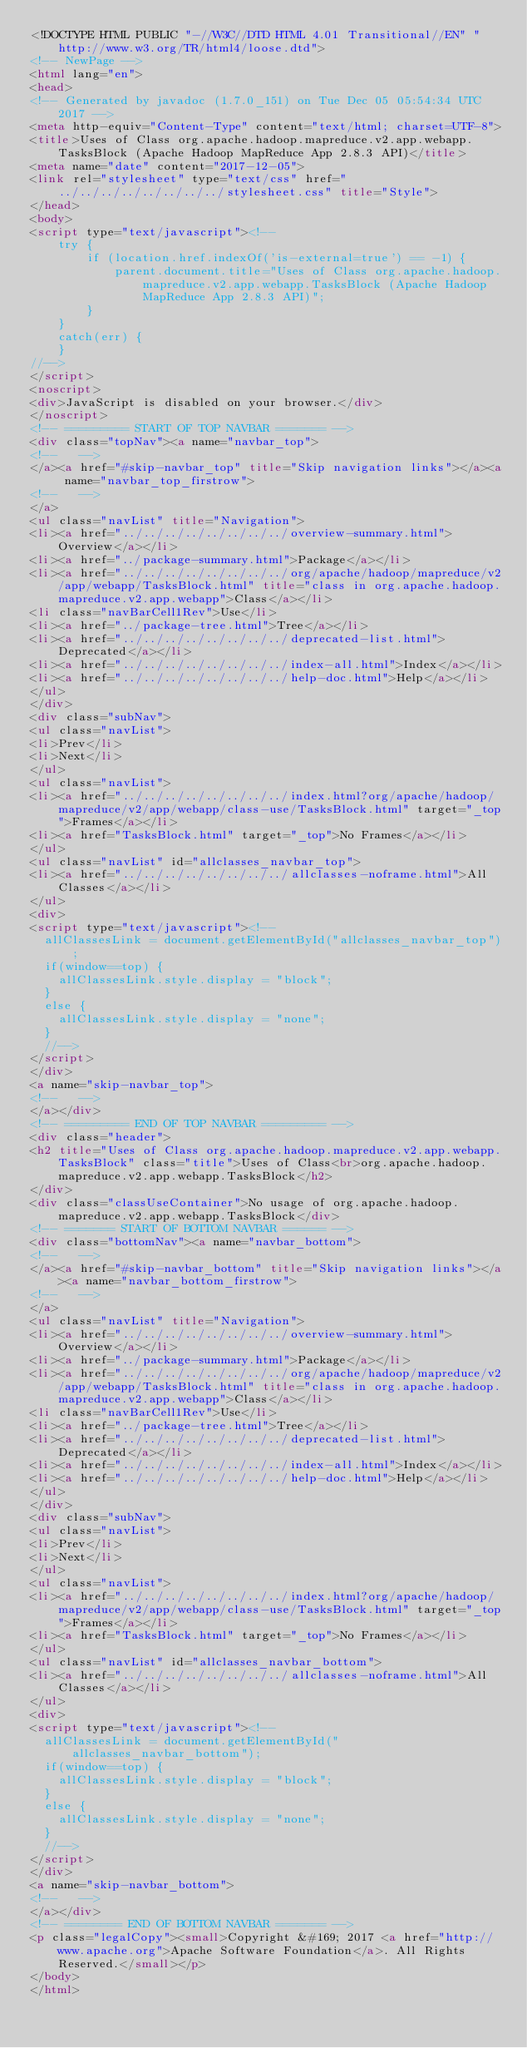Convert code to text. <code><loc_0><loc_0><loc_500><loc_500><_HTML_><!DOCTYPE HTML PUBLIC "-//W3C//DTD HTML 4.01 Transitional//EN" "http://www.w3.org/TR/html4/loose.dtd">
<!-- NewPage -->
<html lang="en">
<head>
<!-- Generated by javadoc (1.7.0_151) on Tue Dec 05 05:54:34 UTC 2017 -->
<meta http-equiv="Content-Type" content="text/html; charset=UTF-8">
<title>Uses of Class org.apache.hadoop.mapreduce.v2.app.webapp.TasksBlock (Apache Hadoop MapReduce App 2.8.3 API)</title>
<meta name="date" content="2017-12-05">
<link rel="stylesheet" type="text/css" href="../../../../../../../../stylesheet.css" title="Style">
</head>
<body>
<script type="text/javascript"><!--
    try {
        if (location.href.indexOf('is-external=true') == -1) {
            parent.document.title="Uses of Class org.apache.hadoop.mapreduce.v2.app.webapp.TasksBlock (Apache Hadoop MapReduce App 2.8.3 API)";
        }
    }
    catch(err) {
    }
//-->
</script>
<noscript>
<div>JavaScript is disabled on your browser.</div>
</noscript>
<!-- ========= START OF TOP NAVBAR ======= -->
<div class="topNav"><a name="navbar_top">
<!--   -->
</a><a href="#skip-navbar_top" title="Skip navigation links"></a><a name="navbar_top_firstrow">
<!--   -->
</a>
<ul class="navList" title="Navigation">
<li><a href="../../../../../../../../overview-summary.html">Overview</a></li>
<li><a href="../package-summary.html">Package</a></li>
<li><a href="../../../../../../../../org/apache/hadoop/mapreduce/v2/app/webapp/TasksBlock.html" title="class in org.apache.hadoop.mapreduce.v2.app.webapp">Class</a></li>
<li class="navBarCell1Rev">Use</li>
<li><a href="../package-tree.html">Tree</a></li>
<li><a href="../../../../../../../../deprecated-list.html">Deprecated</a></li>
<li><a href="../../../../../../../../index-all.html">Index</a></li>
<li><a href="../../../../../../../../help-doc.html">Help</a></li>
</ul>
</div>
<div class="subNav">
<ul class="navList">
<li>Prev</li>
<li>Next</li>
</ul>
<ul class="navList">
<li><a href="../../../../../../../../index.html?org/apache/hadoop/mapreduce/v2/app/webapp/class-use/TasksBlock.html" target="_top">Frames</a></li>
<li><a href="TasksBlock.html" target="_top">No Frames</a></li>
</ul>
<ul class="navList" id="allclasses_navbar_top">
<li><a href="../../../../../../../../allclasses-noframe.html">All Classes</a></li>
</ul>
<div>
<script type="text/javascript"><!--
  allClassesLink = document.getElementById("allclasses_navbar_top");
  if(window==top) {
    allClassesLink.style.display = "block";
  }
  else {
    allClassesLink.style.display = "none";
  }
  //-->
</script>
</div>
<a name="skip-navbar_top">
<!--   -->
</a></div>
<!-- ========= END OF TOP NAVBAR ========= -->
<div class="header">
<h2 title="Uses of Class org.apache.hadoop.mapreduce.v2.app.webapp.TasksBlock" class="title">Uses of Class<br>org.apache.hadoop.mapreduce.v2.app.webapp.TasksBlock</h2>
</div>
<div class="classUseContainer">No usage of org.apache.hadoop.mapreduce.v2.app.webapp.TasksBlock</div>
<!-- ======= START OF BOTTOM NAVBAR ====== -->
<div class="bottomNav"><a name="navbar_bottom">
<!--   -->
</a><a href="#skip-navbar_bottom" title="Skip navigation links"></a><a name="navbar_bottom_firstrow">
<!--   -->
</a>
<ul class="navList" title="Navigation">
<li><a href="../../../../../../../../overview-summary.html">Overview</a></li>
<li><a href="../package-summary.html">Package</a></li>
<li><a href="../../../../../../../../org/apache/hadoop/mapreduce/v2/app/webapp/TasksBlock.html" title="class in org.apache.hadoop.mapreduce.v2.app.webapp">Class</a></li>
<li class="navBarCell1Rev">Use</li>
<li><a href="../package-tree.html">Tree</a></li>
<li><a href="../../../../../../../../deprecated-list.html">Deprecated</a></li>
<li><a href="../../../../../../../../index-all.html">Index</a></li>
<li><a href="../../../../../../../../help-doc.html">Help</a></li>
</ul>
</div>
<div class="subNav">
<ul class="navList">
<li>Prev</li>
<li>Next</li>
</ul>
<ul class="navList">
<li><a href="../../../../../../../../index.html?org/apache/hadoop/mapreduce/v2/app/webapp/class-use/TasksBlock.html" target="_top">Frames</a></li>
<li><a href="TasksBlock.html" target="_top">No Frames</a></li>
</ul>
<ul class="navList" id="allclasses_navbar_bottom">
<li><a href="../../../../../../../../allclasses-noframe.html">All Classes</a></li>
</ul>
<div>
<script type="text/javascript"><!--
  allClassesLink = document.getElementById("allclasses_navbar_bottom");
  if(window==top) {
    allClassesLink.style.display = "block";
  }
  else {
    allClassesLink.style.display = "none";
  }
  //-->
</script>
</div>
<a name="skip-navbar_bottom">
<!--   -->
</a></div>
<!-- ======== END OF BOTTOM NAVBAR ======= -->
<p class="legalCopy"><small>Copyright &#169; 2017 <a href="http://www.apache.org">Apache Software Foundation</a>. All Rights Reserved.</small></p>
</body>
</html>
</code> 